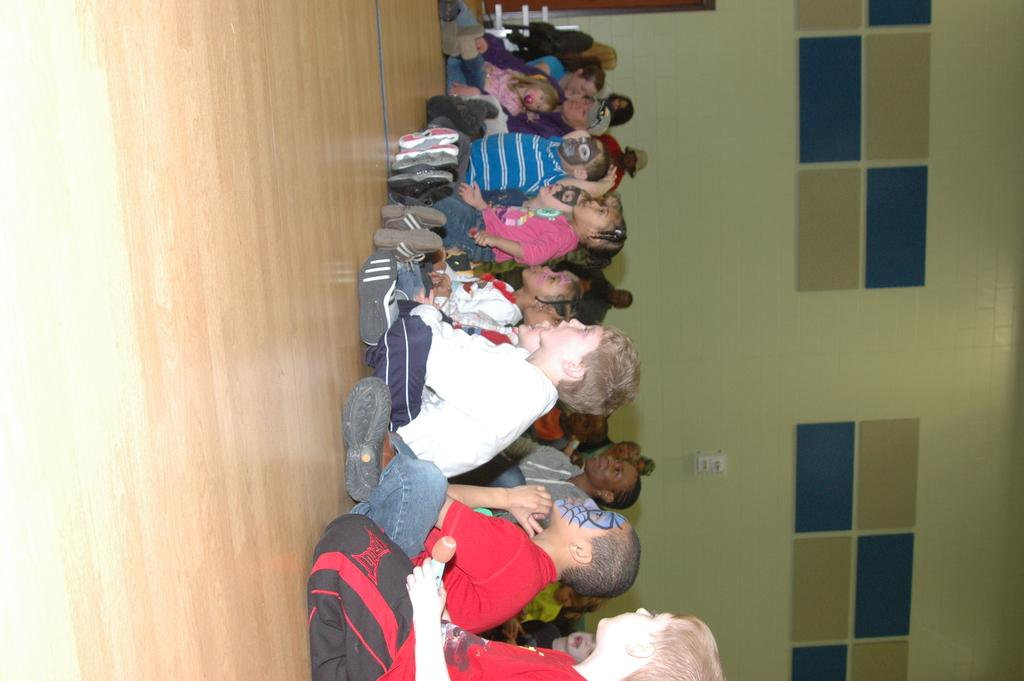What is the main subject of the image? The main subject of the image is a group of children. Where are the children sitting in the image? The children are sitting on a wooden floor. Are there any other people in the image besides the children? Yes, there are women in the image. What are some of the children wearing on their faces? Some children are wearing costumes on their faces. Is there a stream of liquid flowing through the image? No, there is no stream of liquid present in the image. What type of range can be seen in the image? There is no range visible in the image; it features a group of children sitting on a wooden floor. 